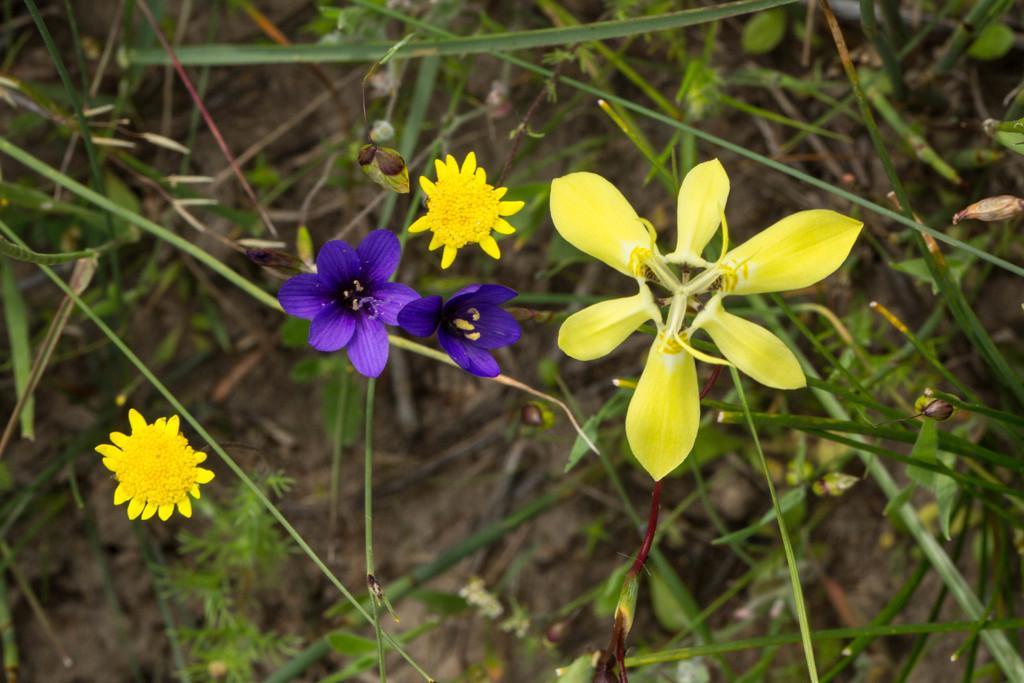Can you describe this image briefly? In this picture we can see some yellow and purple flowers. Few plants are visible in the background. 